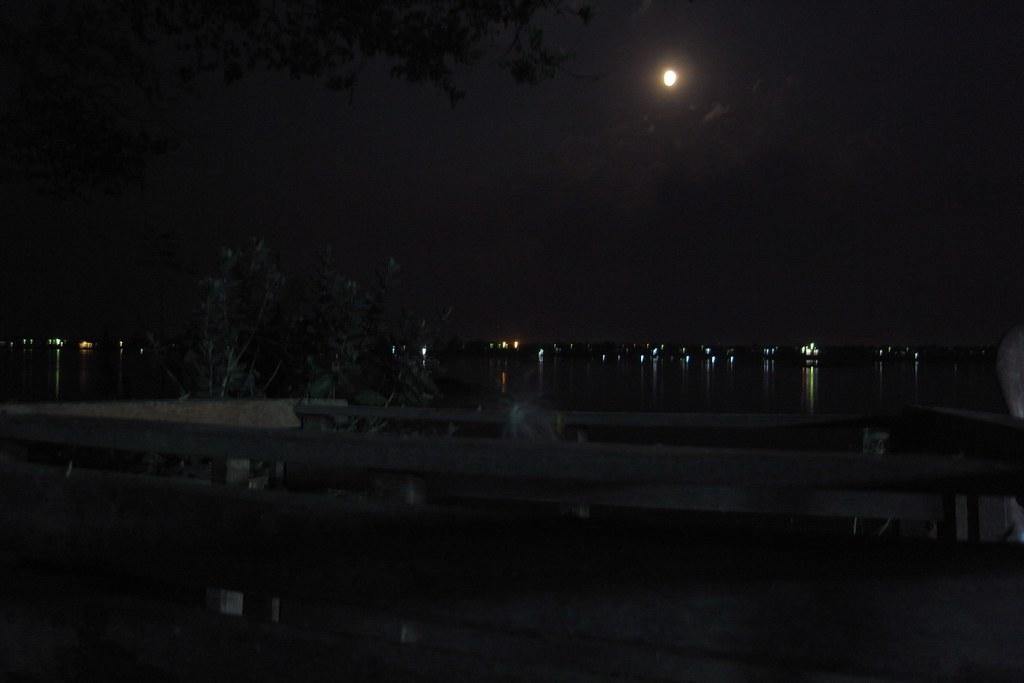Could you give a brief overview of what you see in this image? In this image there is a river and fencing, in the background there are lights there is a sky, in that sky there is a moon. 